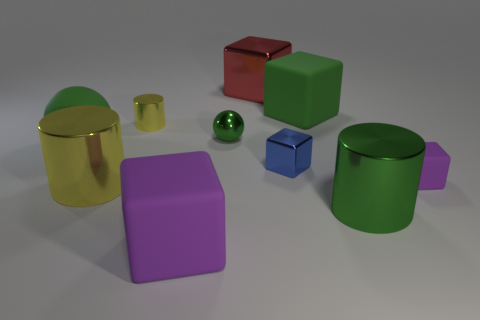Which objects in the image look metallic? The two cylindrical objects, one golden and one green, exhibit a metallic sheen, suggesting that they could be made of a metallic material or are designed to mimic one. 